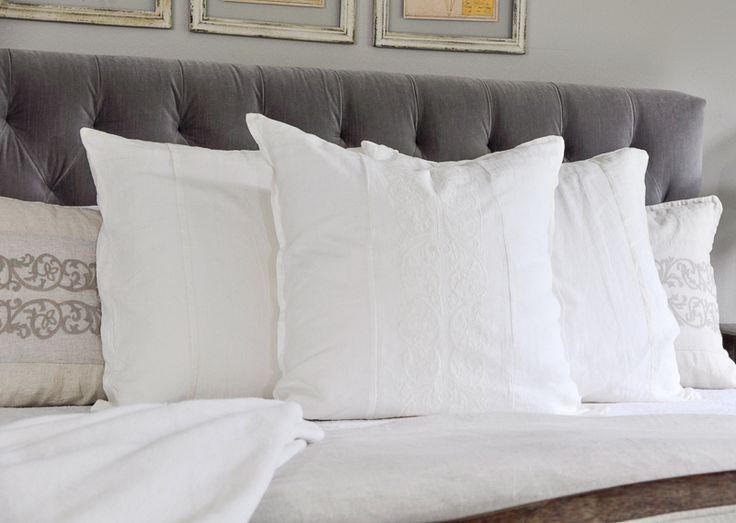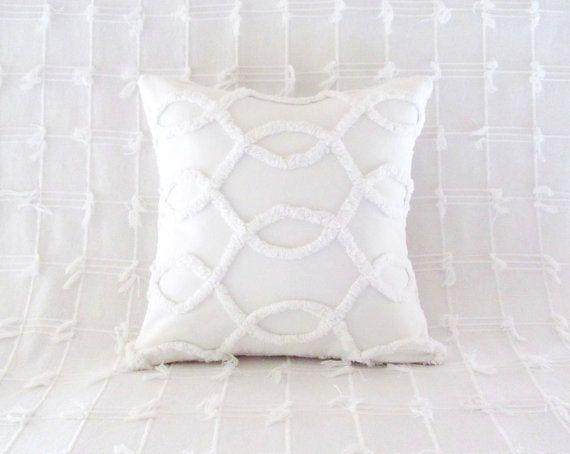The first image is the image on the left, the second image is the image on the right. For the images displayed, is the sentence "multiple pillows are stacked on top of each other" factually correct? Answer yes or no. No. The first image is the image on the left, the second image is the image on the right. For the images shown, is this caption "No less than four white pillows are stacked directly on top of one another" true? Answer yes or no. No. 